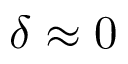<formula> <loc_0><loc_0><loc_500><loc_500>\delta \approx 0</formula> 